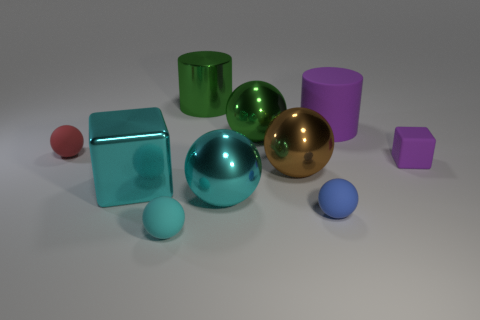There is a rubber sphere that is to the right of the brown ball; is its size the same as the green metallic cylinder?
Provide a succinct answer. No. What number of matte things are either large brown objects or small objects?
Offer a very short reply. 4. There is a large cylinder to the right of the big brown ball; what number of large brown things are behind it?
Make the answer very short. 0. What shape is the thing that is both on the right side of the tiny red rubber object and left of the tiny cyan matte object?
Offer a very short reply. Cube. What is the material of the big cylinder right of the cylinder that is to the left of the sphere that is behind the red matte object?
Provide a short and direct response. Rubber. There is a cylinder that is the same color as the rubber cube; what is its size?
Offer a very short reply. Large. What is the material of the blue thing?
Offer a very short reply. Rubber. Is the material of the small cyan sphere the same as the big green ball behind the blue thing?
Provide a succinct answer. No. The block to the left of the cyan object that is in front of the blue rubber thing is what color?
Your answer should be very brief. Cyan. What size is the rubber thing that is both left of the purple cylinder and behind the metallic cube?
Offer a terse response. Small. 